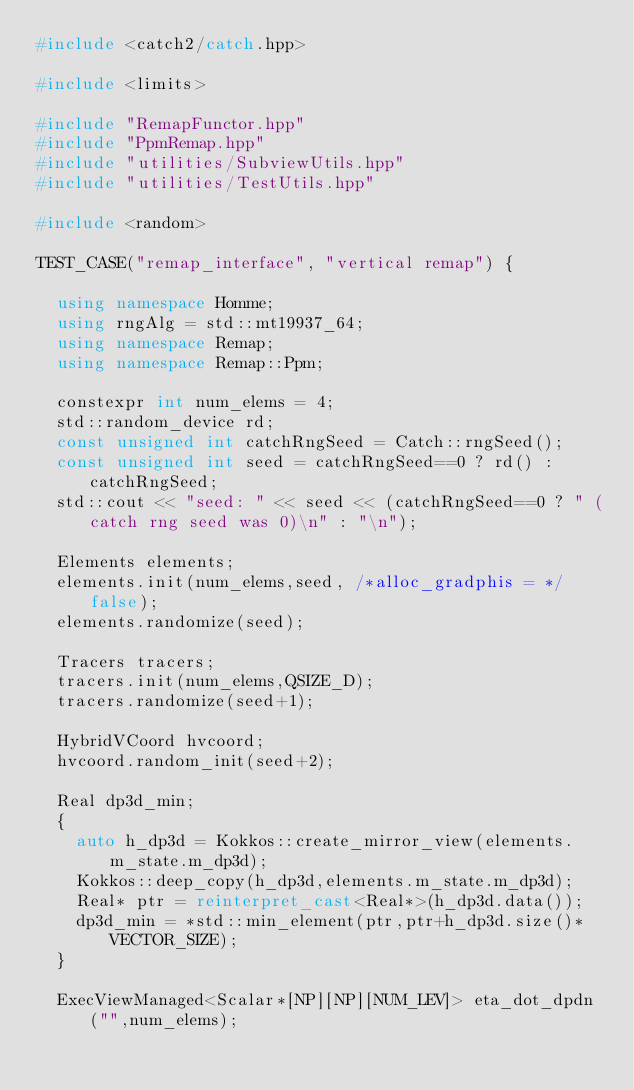<code> <loc_0><loc_0><loc_500><loc_500><_C++_>#include <catch2/catch.hpp>

#include <limits>

#include "RemapFunctor.hpp"
#include "PpmRemap.hpp"
#include "utilities/SubviewUtils.hpp"
#include "utilities/TestUtils.hpp"

#include <random>

TEST_CASE("remap_interface", "vertical remap") {

  using namespace Homme;
  using rngAlg = std::mt19937_64;
  using namespace Remap;
  using namespace Remap::Ppm;

  constexpr int num_elems = 4;
  std::random_device rd;
  const unsigned int catchRngSeed = Catch::rngSeed();
  const unsigned int seed = catchRngSeed==0 ? rd() : catchRngSeed;
  std::cout << "seed: " << seed << (catchRngSeed==0 ? " (catch rng seed was 0)\n" : "\n");

  Elements elements;
  elements.init(num_elems,seed, /*alloc_gradphis = */ false);
  elements.randomize(seed);

  Tracers tracers;
  tracers.init(num_elems,QSIZE_D);
  tracers.randomize(seed+1);

  HybridVCoord hvcoord;
  hvcoord.random_init(seed+2);

  Real dp3d_min;
  {
    auto h_dp3d = Kokkos::create_mirror_view(elements.m_state.m_dp3d);
    Kokkos::deep_copy(h_dp3d,elements.m_state.m_dp3d);
    Real* ptr = reinterpret_cast<Real*>(h_dp3d.data());
    dp3d_min = *std::min_element(ptr,ptr+h_dp3d.size()*VECTOR_SIZE);
  }

  ExecViewManaged<Scalar*[NP][NP][NUM_LEV]> eta_dot_dpdn ("",num_elems);</code> 